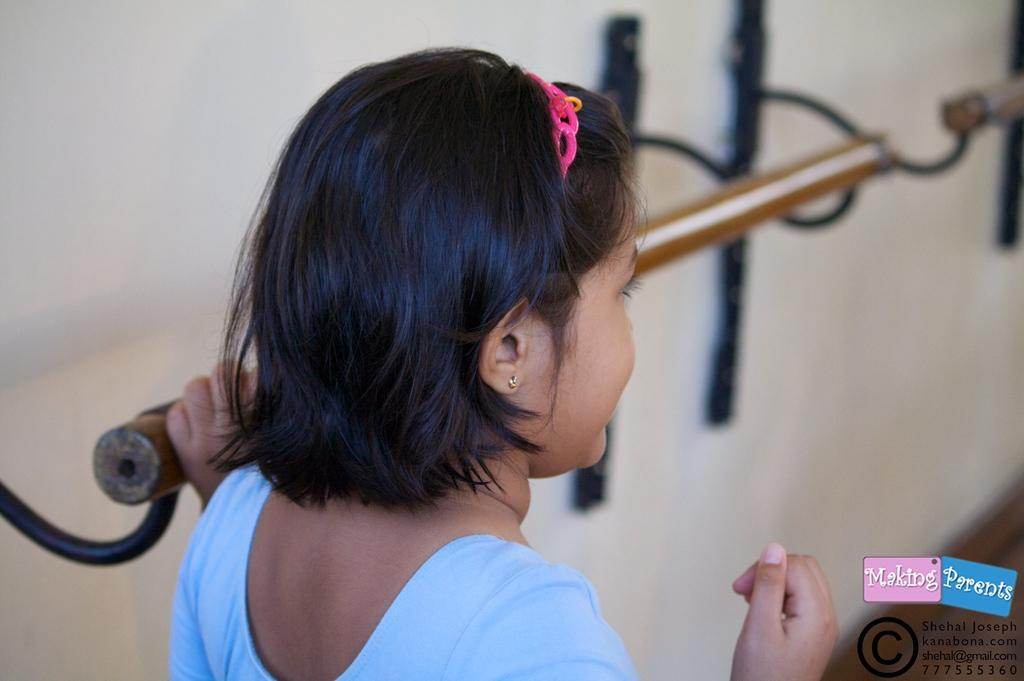Who is the main subject in the image? There is a girl in the image. What is the girl wearing? The girl is wearing a blue dress. What can be seen in the background of the image? There is a wall and a stand in the background of the image. Is there any additional information about the image itself? Yes, there is a watermark in the right bottom of the image. What type of sock is the girl wearing in the image? There is no sock visible in the image; the girl is wearing a blue dress. Can you tell me how many cakes are on the stand in the image? There is no stand with cakes present in the image; there is only a stand in the background. 